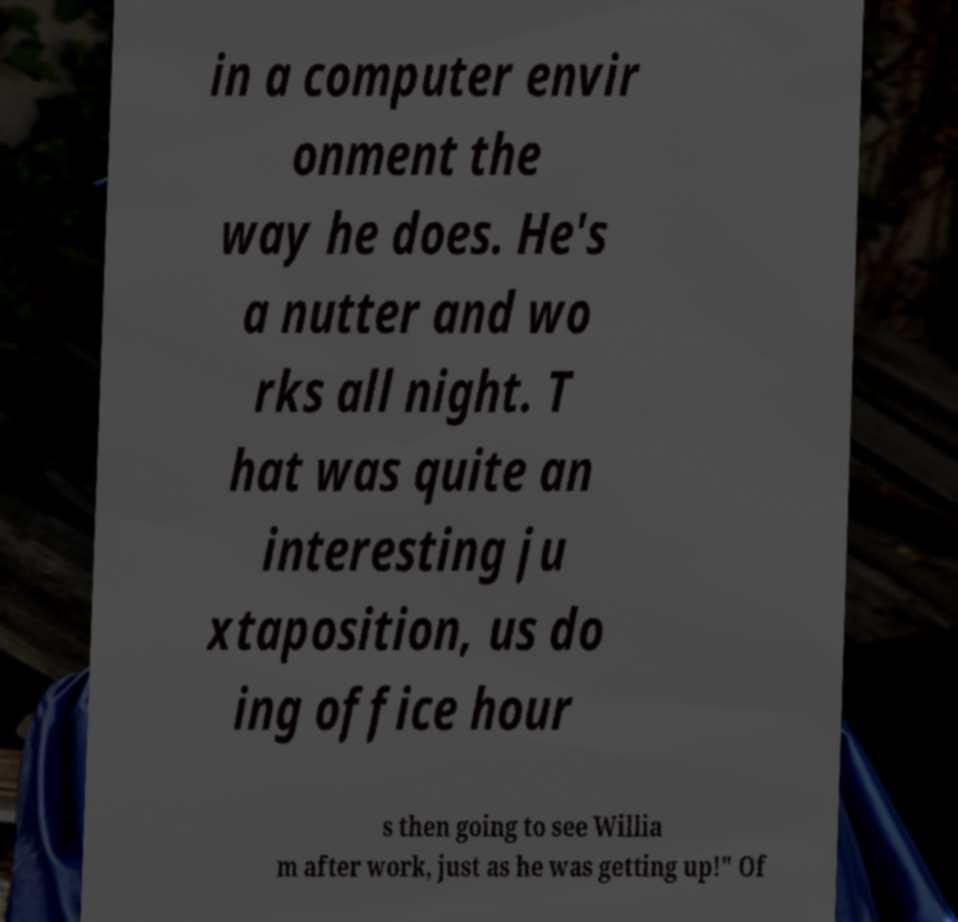Please read and relay the text visible in this image. What does it say? in a computer envir onment the way he does. He's a nutter and wo rks all night. T hat was quite an interesting ju xtaposition, us do ing office hour s then going to see Willia m after work, just as he was getting up!" Of 